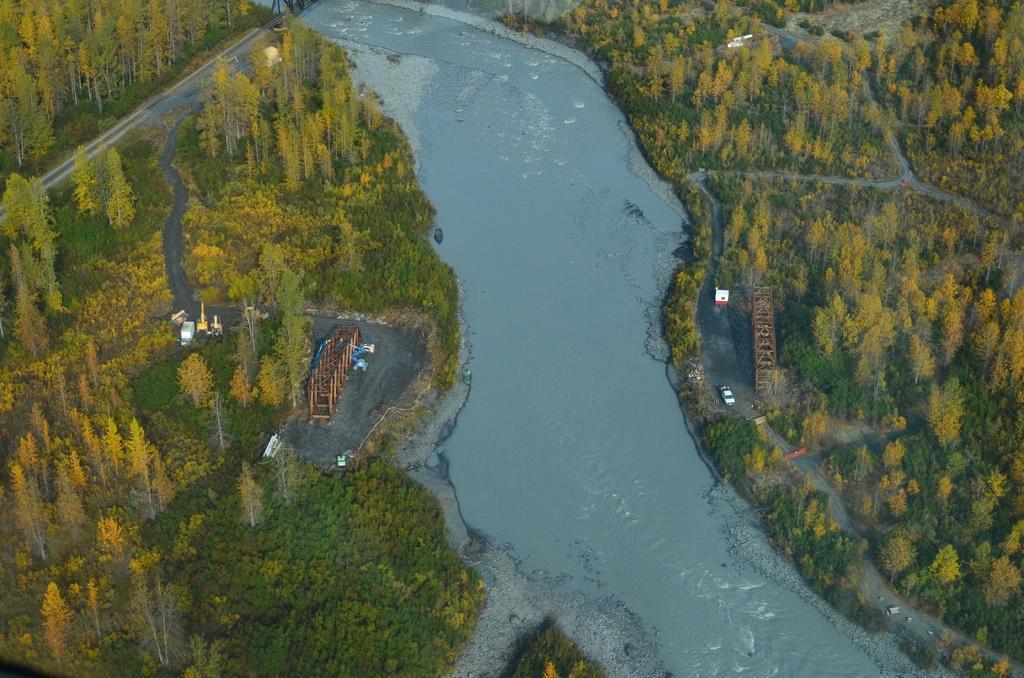Could you give a brief overview of what you see in this image? In this image I can see an aerial view. There is water in the center. There are trees on the either sides. 